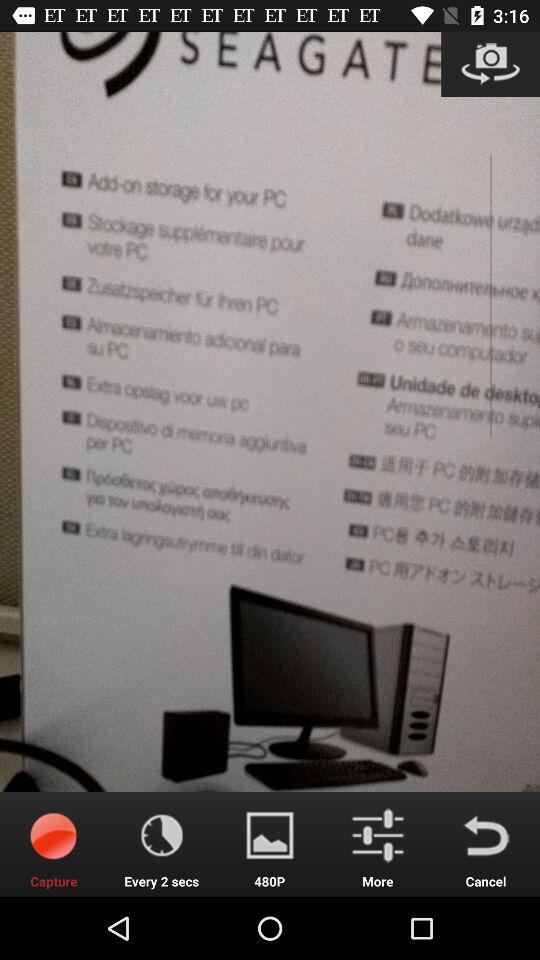Which tab is currently selected? The currently selected tab is "Capture". 